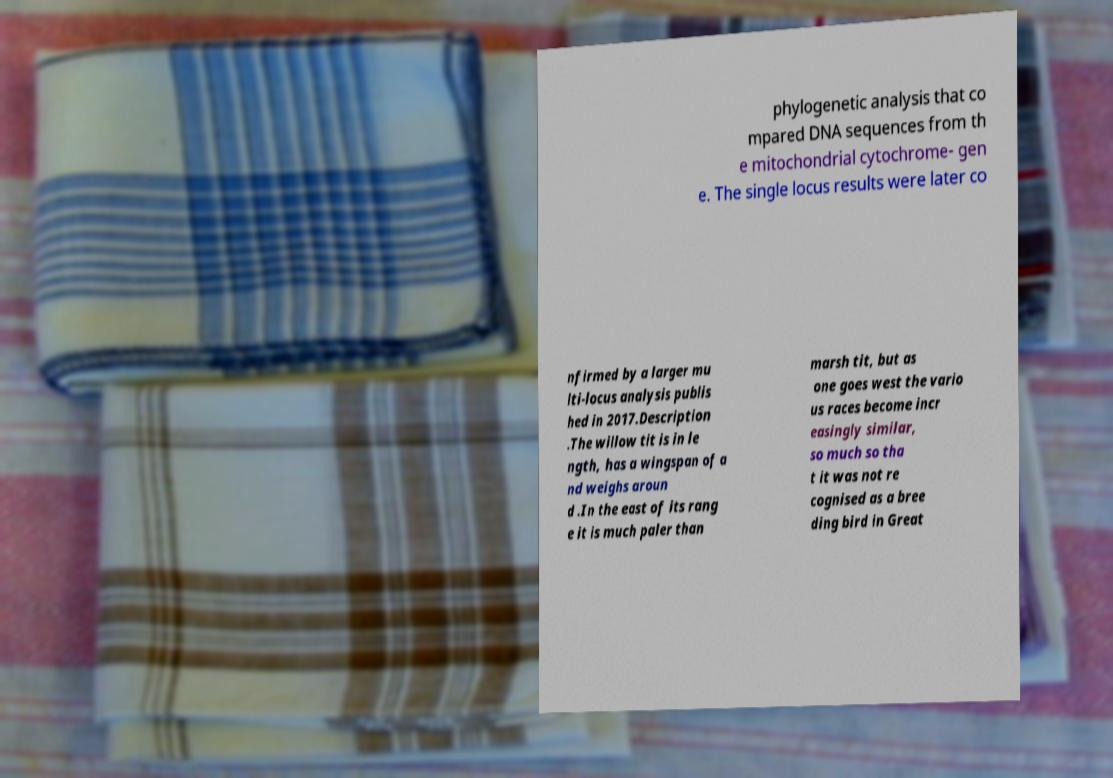Please read and relay the text visible in this image. What does it say? phylogenetic analysis that co mpared DNA sequences from th e mitochondrial cytochrome- gen e. The single locus results were later co nfirmed by a larger mu lti-locus analysis publis hed in 2017.Description .The willow tit is in le ngth, has a wingspan of a nd weighs aroun d .In the east of its rang e it is much paler than marsh tit, but as one goes west the vario us races become incr easingly similar, so much so tha t it was not re cognised as a bree ding bird in Great 